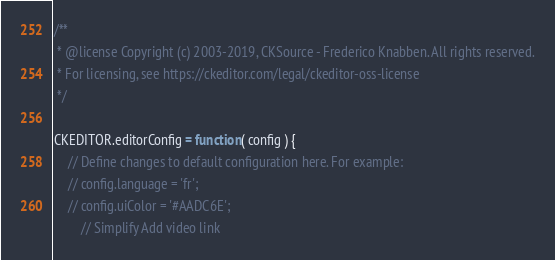Convert code to text. <code><loc_0><loc_0><loc_500><loc_500><_JavaScript_>/**
 * @license Copyright (c) 2003-2019, CKSource - Frederico Knabben. All rights reserved.
 * For licensing, see https://ckeditor.com/legal/ckeditor-oss-license
 */

CKEDITOR.editorConfig = function( config ) {
	// Define changes to default configuration here. For example:
	// config.language = 'fr';
	// config.uiColor = '#AADC6E';
		// Simplify Add video link</code> 